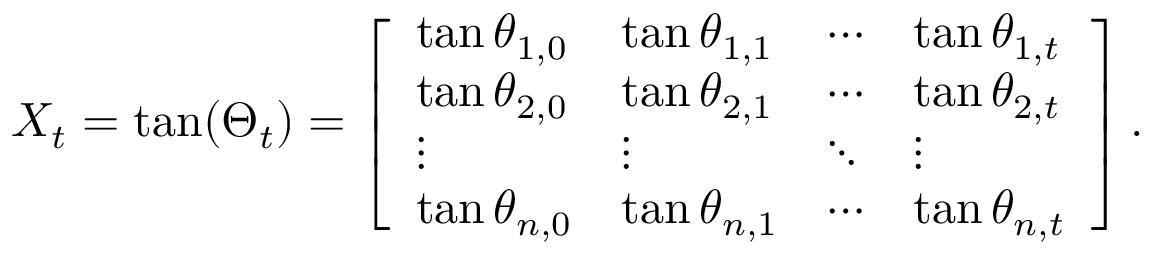<formula> <loc_0><loc_0><loc_500><loc_500>X _ { t } = \tan ( \Theta _ { t } ) = \left [ \begin{array} { l l l l } { \tan \theta _ { 1 , 0 } } & { \tan \theta _ { 1 , 1 } } & { \cdots } & { \tan \theta _ { 1 , t } } \\ { \tan \theta _ { 2 , 0 } } & { \tan \theta _ { 2 , 1 } } & { \cdots } & { \tan \theta _ { 2 , t } } \\ { \vdots } & { \vdots } & { \ddots } & { \vdots } \\ { \tan \theta _ { n , 0 } } & { \tan \theta _ { n , 1 } } & { \cdots } & { \tan \theta _ { n , t } } \end{array} \right ] .</formula> 